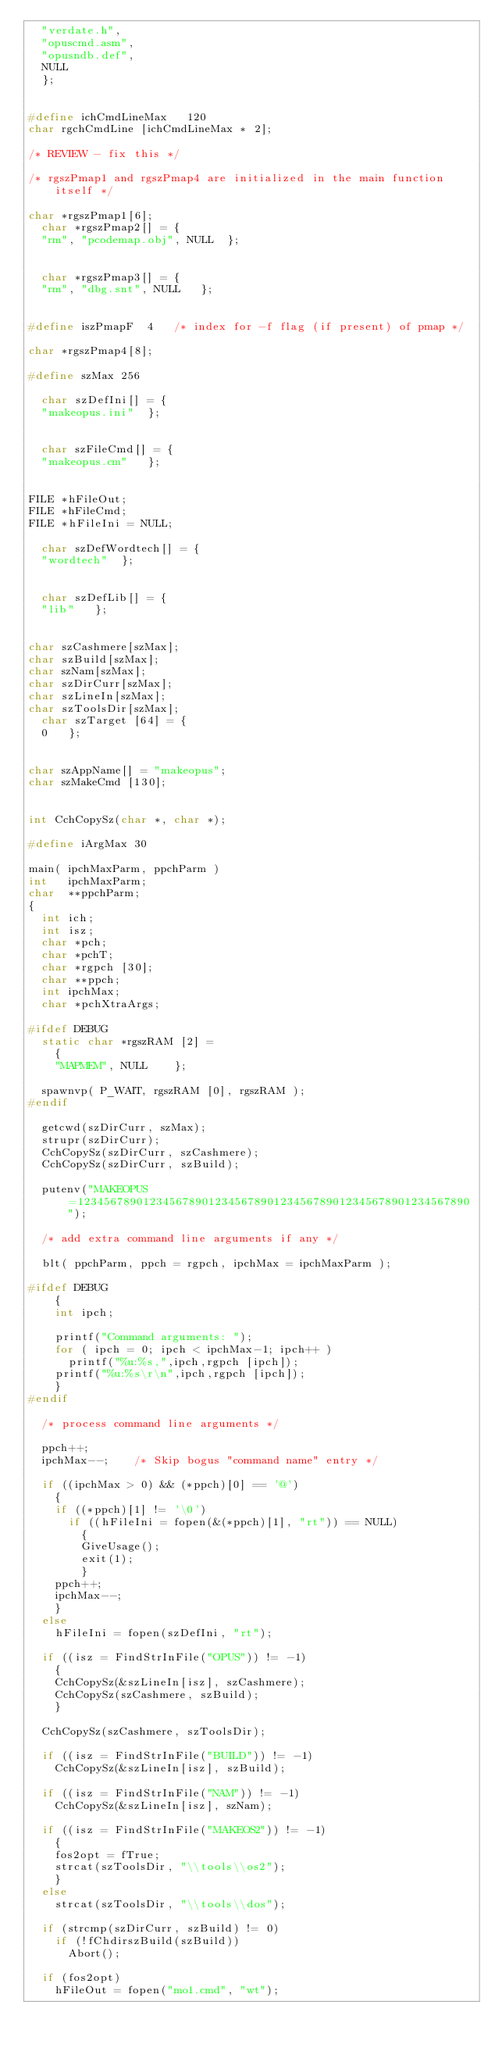Convert code to text. <code><loc_0><loc_0><loc_500><loc_500><_C_>	"verdate.h",
	"opuscmd.asm",
	"opusndb.def",
	NULL
	};


#define ichCmdLineMax   120
char rgchCmdLine [ichCmdLineMax * 2];

/* REVIEW - fix this */

/* rgszPmap1 and rgszPmap4 are initialized in the main function itself */

char *rgszPmap1[6];
	char *rgszPmap2[] = { 
	"rm", "pcodemap.obj", NULL 	};


	char *rgszPmap3[] = { 
	"rm", "dbg.snt", NULL 	};


#define iszPmapF  4   /* index for -f flag (if present) of pmap */

char *rgszPmap4[8];

#define szMax 256

	char szDefIni[] = { 
	"makeopus.ini" 	};


	char szFileCmd[] = { 
	"makeopus.cm" 	};


FILE *hFileOut;
FILE *hFileCmd;
FILE *hFileIni = NULL;

	char szDefWordtech[] = { 
	"wordtech" 	};


	char szDefLib[] = { 
	"lib" 	};


char szCashmere[szMax];
char szBuild[szMax];
char szNam[szMax];
char szDirCurr[szMax];
char szLineIn[szMax];
char szToolsDir[szMax];
	char szTarget [64] = { 
	0 	};


char szAppName[] = "makeopus";
char szMakeCmd [130];


int CchCopySz(char *, char *);

#define iArgMax 30

main( ipchMaxParm, ppchParm )
int   ipchMaxParm;
char  **ppchParm;
{
	int ich;
	int isz;
	char *pch;
	char *pchT;
	char *rgpch [30];
	char **ppch;
	int ipchMax;
	char *pchXtraArgs;

#ifdef DEBUG
	static char *rgszRAM [2] = 
		{ 
		"MAPMEM", NULL 		};

	spawnvp( P_WAIT, rgszRAM [0], rgszRAM );
#endif

	getcwd(szDirCurr, szMax);
	strupr(szDirCurr);
	CchCopySz(szDirCurr, szCashmere);
	CchCopySz(szDirCurr, szBuild);

	putenv("MAKEOPUS=123456789012345678901234567890123456789012345678901234567890");

	/* add extra command line arguments if any */

	blt( ppchParm, ppch = rgpch, ipchMax = ipchMaxParm );

#ifdef DEBUG
		{
		int ipch;

		printf("Command arguments: ");
		for ( ipch = 0; ipch < ipchMax-1; ipch++ )
			printf("%u:%s,",ipch,rgpch [ipch]);
		printf("%u:%s\r\n",ipch,rgpch [ipch]);
		}
#endif

	/* process command line arguments */

	ppch++;  
	ipchMax--;    /* Skip bogus "command name" entry */

	if ((ipchMax > 0) && (*ppch)[0] == '@')
		{
		if ((*ppch)[1] != '\0')
			if ((hFileIni = fopen(&(*ppch)[1], "rt")) == NULL)
				{
				GiveUsage();
				exit(1);
				}
		ppch++;
		ipchMax--;
		}
	else
		hFileIni = fopen(szDefIni, "rt");

	if ((isz = FindStrInFile("OPUS")) != -1)
		{
		CchCopySz(&szLineIn[isz], szCashmere);
		CchCopySz(szCashmere, szBuild);
		}

	CchCopySz(szCashmere, szToolsDir);

	if ((isz = FindStrInFile("BUILD")) != -1)
		CchCopySz(&szLineIn[isz], szBuild);

	if ((isz = FindStrInFile("NAM")) != -1)
		CchCopySz(&szLineIn[isz], szNam);

	if ((isz = FindStrInFile("MAKEOS2")) != -1)
		{
		fos2opt = fTrue;
		strcat(szToolsDir, "\\tools\\os2");
		}
	else
		strcat(szToolsDir, "\\tools\\dos");

	if (strcmp(szDirCurr, szBuild) != 0)
		if (!fChdirszBuild(szBuild))
			Abort();

	if (fos2opt)
		hFileOut = fopen("mo1.cmd", "wt");</code> 